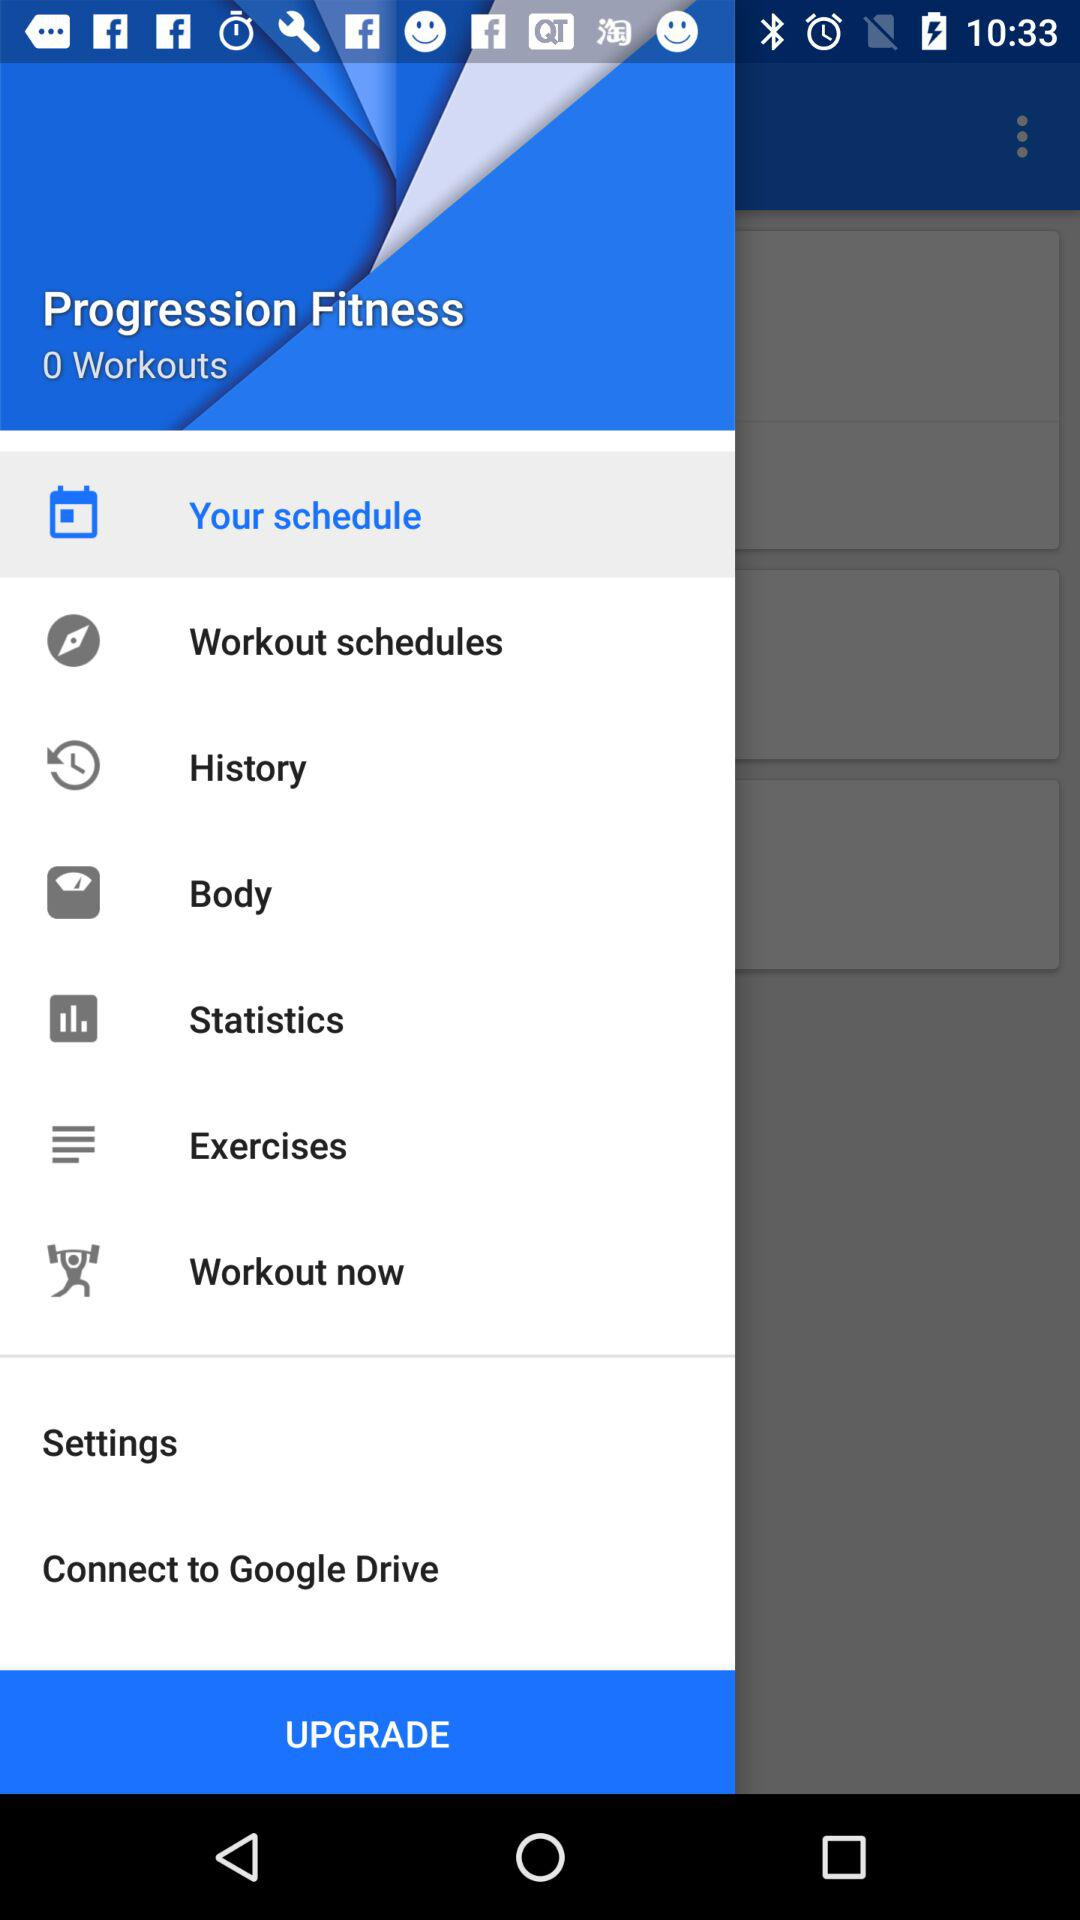Which days of the week are marked as workout days?
When the provided information is insufficient, respond with <no answer>. <no answer> 